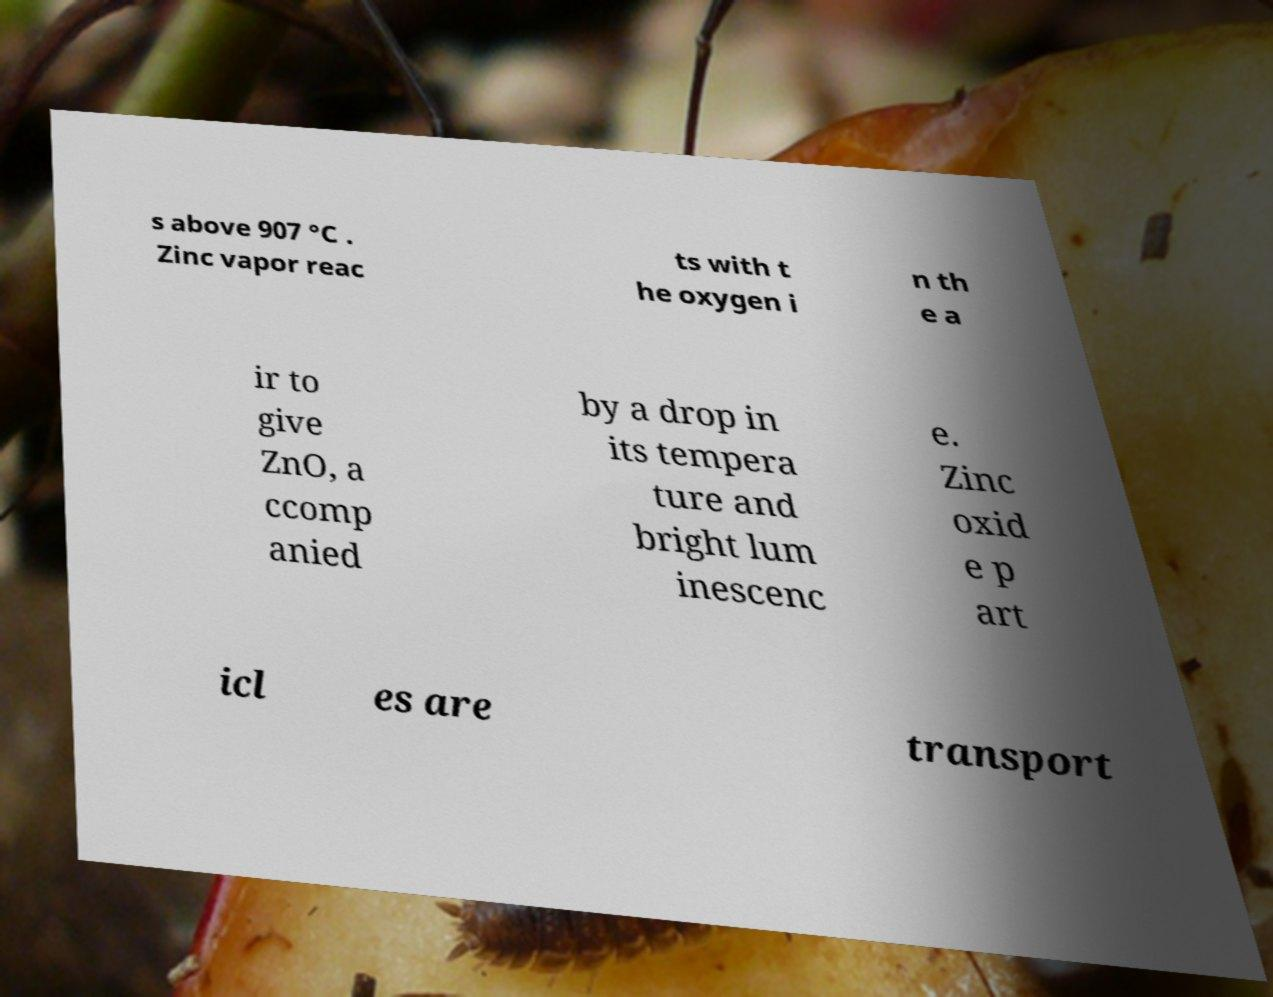Please identify and transcribe the text found in this image. s above 907 °C . Zinc vapor reac ts with t he oxygen i n th e a ir to give ZnO, a ccomp anied by a drop in its tempera ture and bright lum inescenc e. Zinc oxid e p art icl es are transport 